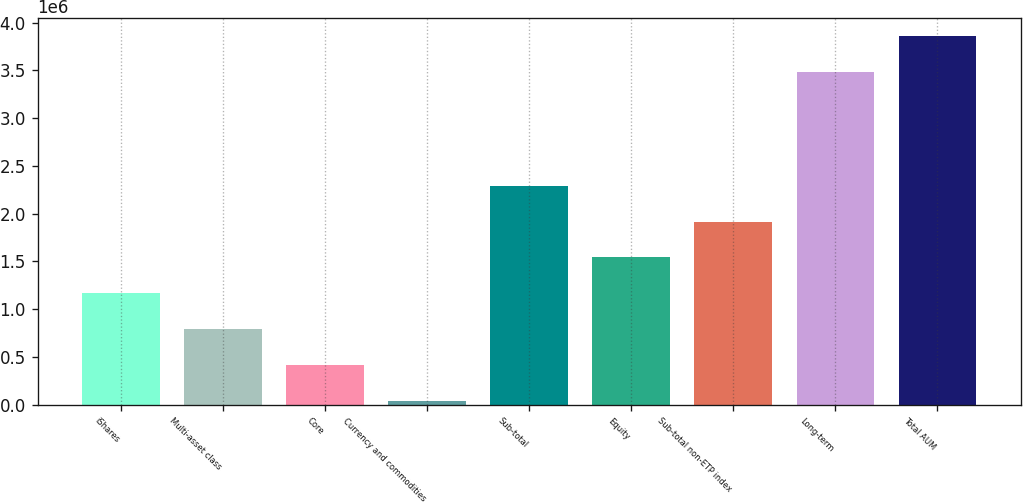Convert chart to OTSL. <chart><loc_0><loc_0><loc_500><loc_500><bar_chart><fcel>iShares<fcel>Multi-asset class<fcel>Core<fcel>Currency and commodities<fcel>Sub-total<fcel>Equity<fcel>Sub-total non-ETP index<fcel>Long-term<fcel>Total AUM<nl><fcel>1.16648e+06<fcel>791460<fcel>416444<fcel>41428<fcel>2.29152e+06<fcel>1.54149e+06<fcel>1.91651e+06<fcel>3.48237e+06<fcel>3.85738e+06<nl></chart> 